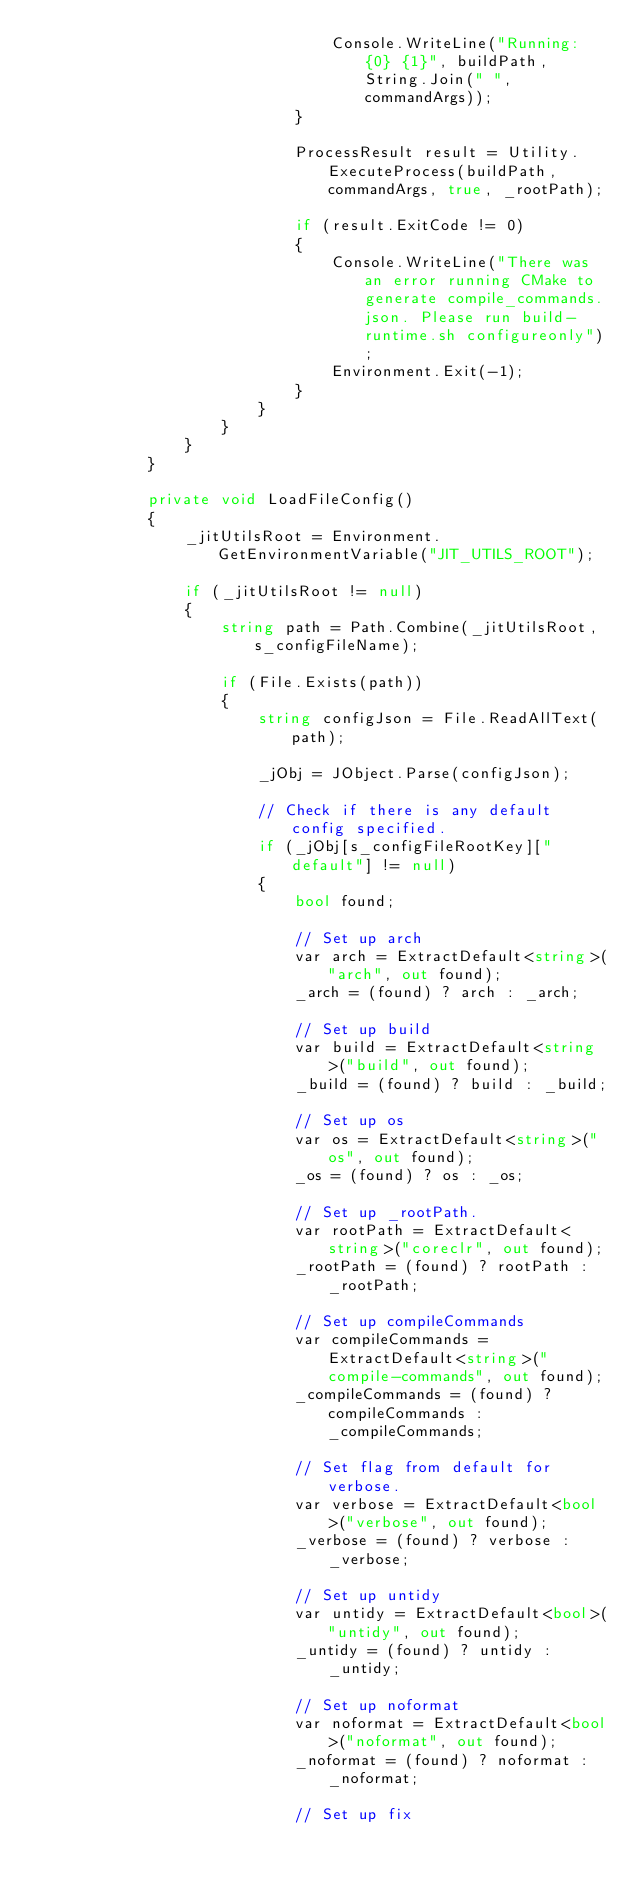Convert code to text. <code><loc_0><loc_0><loc_500><loc_500><_C#_>                                Console.WriteLine("Running: {0} {1}", buildPath, String.Join(" ", commandArgs));
                            }

                            ProcessResult result = Utility.ExecuteProcess(buildPath, commandArgs, true, _rootPath);

                            if (result.ExitCode != 0)
                            {
                                Console.WriteLine("There was an error running CMake to generate compile_commands.json. Please run build-runtime.sh configureonly");
                                Environment.Exit(-1);
                            }
                        }
                    }
                }
            }

            private void LoadFileConfig()
            {
                _jitUtilsRoot = Environment.GetEnvironmentVariable("JIT_UTILS_ROOT");

                if (_jitUtilsRoot != null)
                {
                    string path = Path.Combine(_jitUtilsRoot, s_configFileName);

                    if (File.Exists(path))
                    {
                        string configJson = File.ReadAllText(path);

                        _jObj = JObject.Parse(configJson);
                        
                        // Check if there is any default config specified.
                        if (_jObj[s_configFileRootKey]["default"] != null)
                        {
                            bool found;

                            // Set up arch
                            var arch = ExtractDefault<string>("arch", out found);
                            _arch = (found) ? arch : _arch;

                            // Set up build
                            var build = ExtractDefault<string>("build", out found);
                            _build = (found) ? build : _build;

                            // Set up os
                            var os = ExtractDefault<string>("os", out found);
                            _os = (found) ? os : _os;

                            // Set up _rootPath.
                            var rootPath = ExtractDefault<string>("coreclr", out found);
                            _rootPath = (found) ? rootPath : _rootPath;

                            // Set up compileCommands
                            var compileCommands = ExtractDefault<string>("compile-commands", out found);
                            _compileCommands = (found) ? compileCommands : _compileCommands;

                            // Set flag from default for verbose.
                            var verbose = ExtractDefault<bool>("verbose", out found);
                            _verbose = (found) ? verbose : _verbose;

                            // Set up untidy
                            var untidy = ExtractDefault<bool>("untidy", out found);
                            _untidy = (found) ? untidy : _untidy;

                            // Set up noformat
                            var noformat = ExtractDefault<bool>("noformat", out found);
                            _noformat = (found) ? noformat : _noformat;

                            // Set up fix</code> 